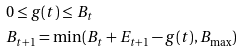Convert formula to latex. <formula><loc_0><loc_0><loc_500><loc_500>& 0 \leq g ( t ) \leq B _ { t } \\ & B _ { t + 1 } = \min ( B _ { t } + E _ { t + 1 } - g ( t ) , B _ { \max } )</formula> 